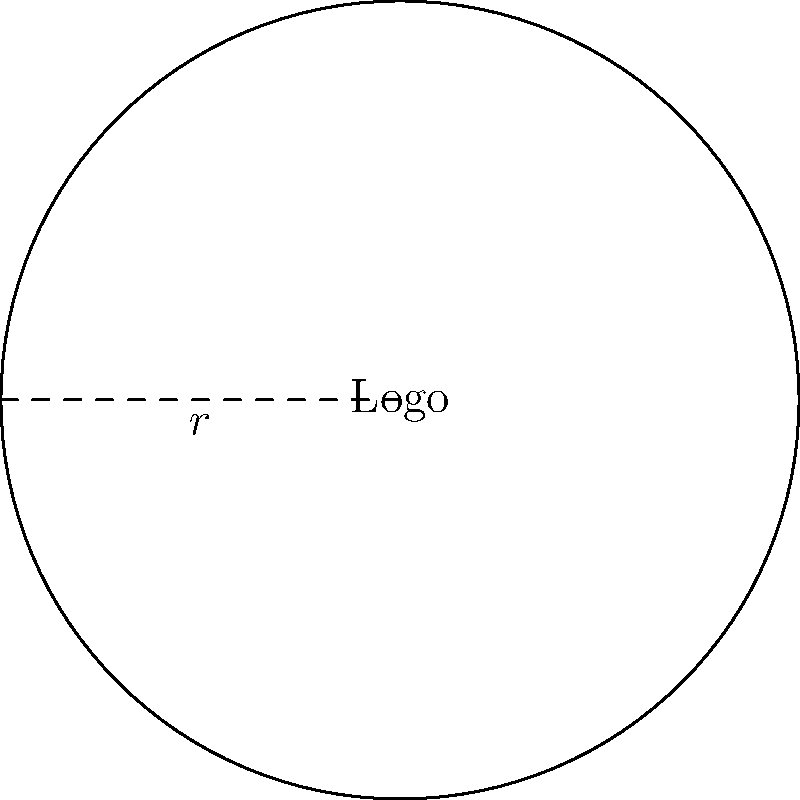As part of your e-commerce website branding, you've designed a circular logo with a radius of 12 cm. Calculate the area of this logo design to determine the appropriate size for displaying it on your homepage. To find the area of a circular logo, we use the formula for the area of a circle:

$$A = \pi r^2$$

Where:
$A$ = Area of the circle
$\pi$ = Pi (approximately 3.14159)
$r$ = Radius of the circle

Given:
Radius $(r) = 12$ cm

Step 1: Substitute the given radius into the formula.
$$A = \pi (12)^2$$

Step 2: Calculate the square of the radius.
$$A = \pi (144)$$

Step 3: Multiply by $\pi$.
$$A = 452.39 \text{ cm}^2$$ (rounded to two decimal places)

Therefore, the area of your circular logo design is approximately 452.39 square centimeters.
Answer: $452.39 \text{ cm}^2$ 